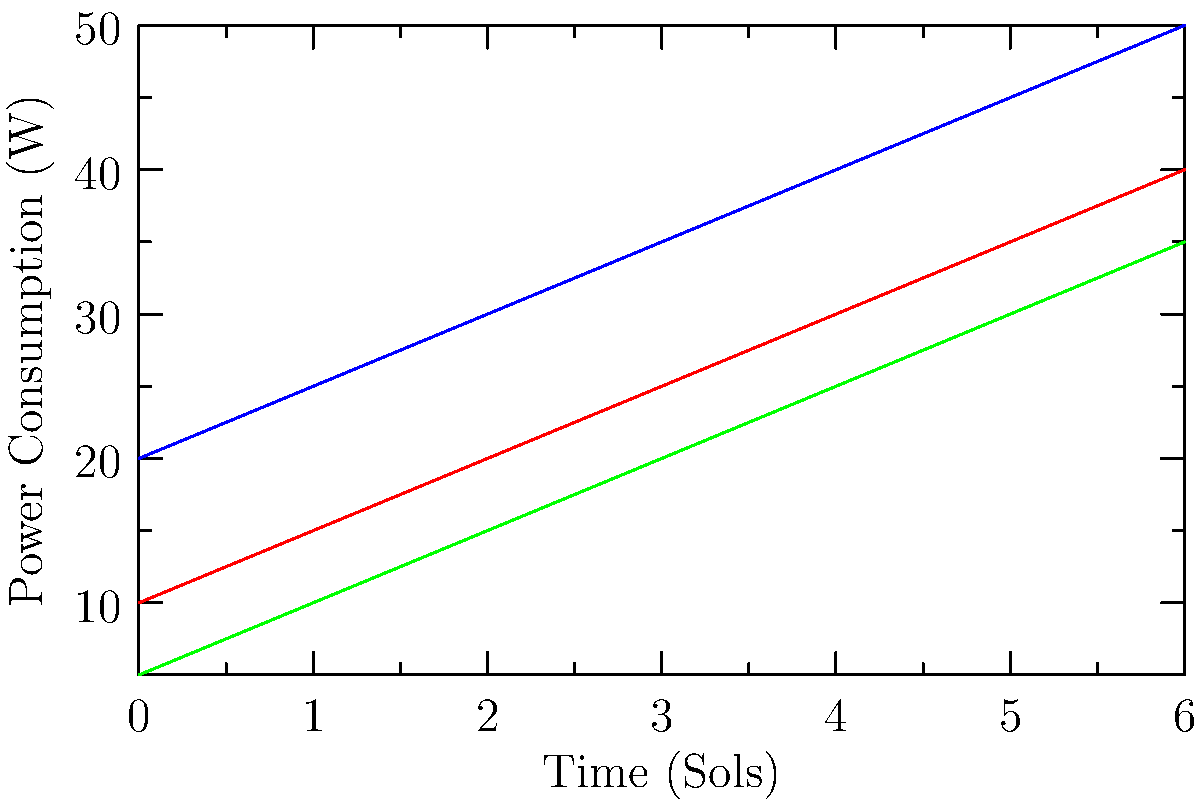Based on the power consumption trends shown in the graph for different rover components during a Mars mission, calculate the total energy consumed by the cameras over the entire 6-sol period. Assume the power consumption changes linearly between data points and express your answer in watt-hours (Wh). To calculate the total energy consumed by the cameras over the 6-sol period:

1. Divide the graph into 6 trapezoids, each representing 1 sol.
2. Calculate the area of each trapezoid using the formula: $A = \frac{1}{2}(b_1 + b_2)h$, where $b_1$ and $b_2$ are the parallel sides (power values) and $h$ is the height (1 sol).
3. Sum the areas of all trapezoids.
4. Convert the result from watt-sols to watt-hours.

Calculations:
1. Trapezoid areas (in watt-sols):
   $A_1 = \frac{1}{2}(20 + 25) \cdot 1 = 22.5$
   $A_2 = \frac{1}{2}(25 + 30) \cdot 1 = 27.5$
   $A_3 = \frac{1}{2}(30 + 35) \cdot 1 = 32.5$
   $A_4 = \frac{1}{2}(35 + 40) \cdot 1 = 37.5$
   $A_5 = \frac{1}{2}(40 + 45) \cdot 1 = 42.5$
   $A_6 = \frac{1}{2}(45 + 50) \cdot 1 = 47.5$

2. Total area: $22.5 + 27.5 + 32.5 + 37.5 + 42.5 + 47.5 = 210$ watt-sols

3. Convert to watt-hours:
   1 sol ≈ 24.65 Earth hours
   $210 \text{ watt-sols} \cdot 24.65 \text{ hours/sol} = 5176.5 \text{ Wh}$

Thus, the total energy consumed by the cameras over the 6-sol period is approximately 5176.5 Wh.
Answer: 5176.5 Wh 